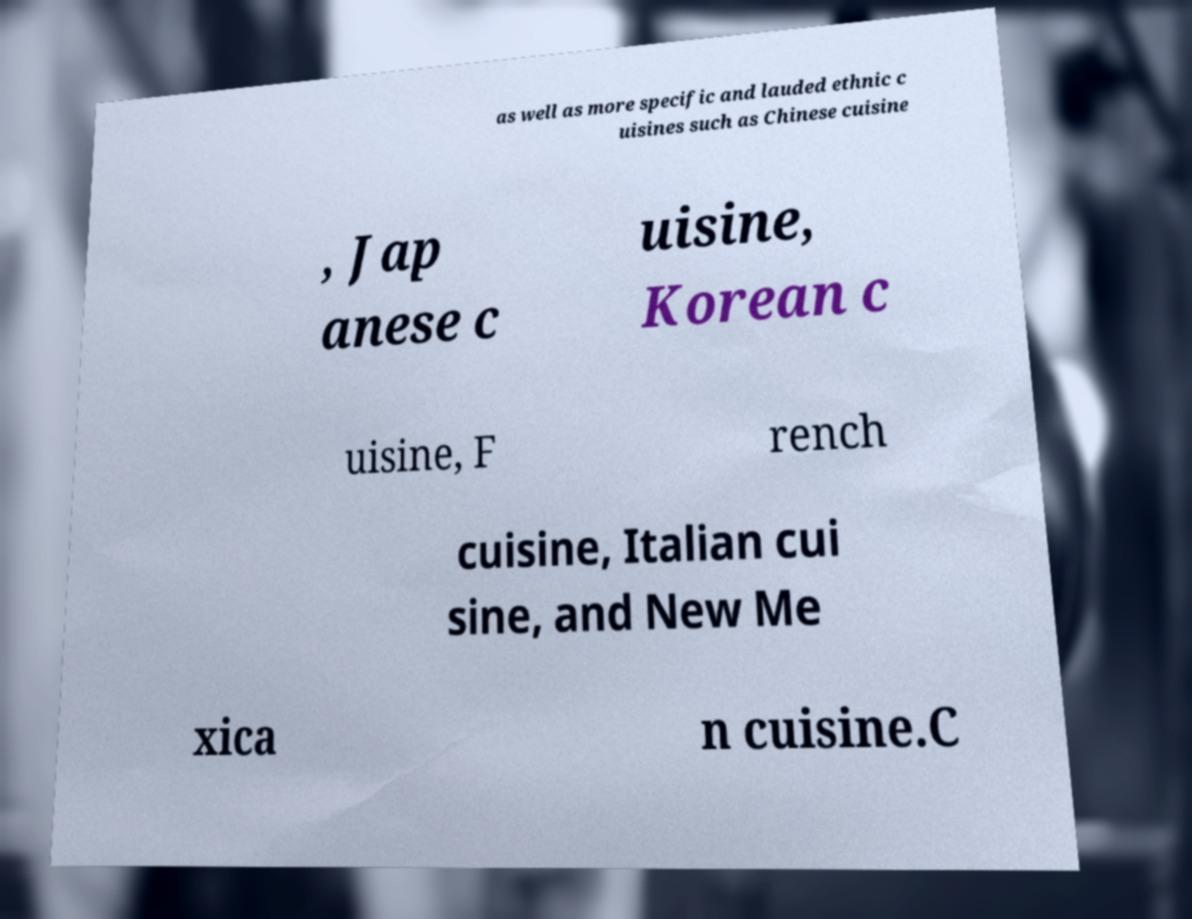I need the written content from this picture converted into text. Can you do that? as well as more specific and lauded ethnic c uisines such as Chinese cuisine , Jap anese c uisine, Korean c uisine, F rench cuisine, Italian cui sine, and New Me xica n cuisine.C 